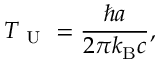Convert formula to latex. <formula><loc_0><loc_0><loc_500><loc_500>T _ { U } = \frac { \hbar { a } } { 2 \pi k _ { B } c } ,</formula> 